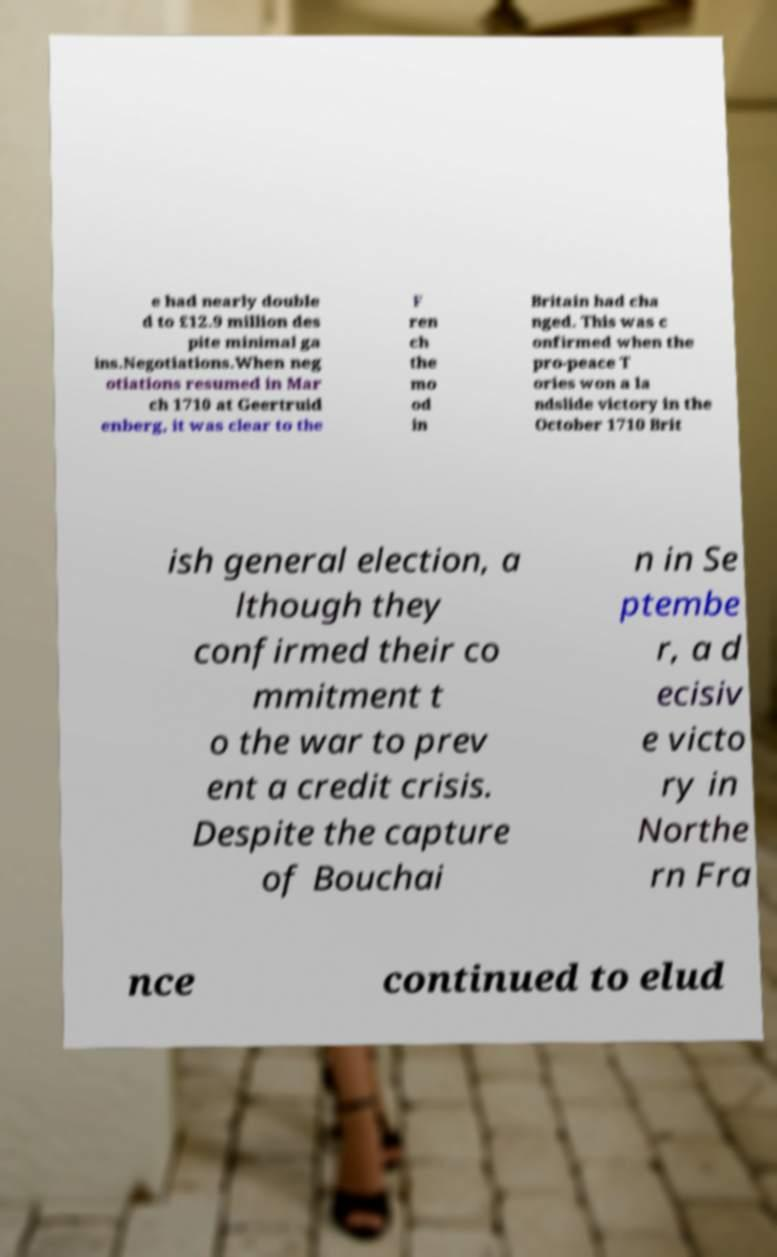What messages or text are displayed in this image? I need them in a readable, typed format. e had nearly double d to £12.9 million des pite minimal ga ins.Negotiations.When neg otiations resumed in Mar ch 1710 at Geertruid enberg, it was clear to the F ren ch the mo od in Britain had cha nged. This was c onfirmed when the pro-peace T ories won a la ndslide victory in the October 1710 Brit ish general election, a lthough they confirmed their co mmitment t o the war to prev ent a credit crisis. Despite the capture of Bouchai n in Se ptembe r, a d ecisiv e victo ry in Northe rn Fra nce continued to elud 